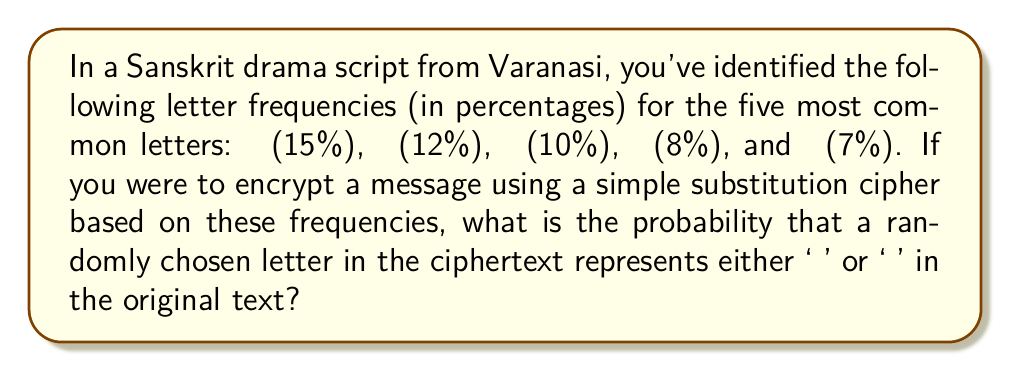Teach me how to tackle this problem. To solve this problem, we'll follow these steps:

1. Identify the relevant frequencies:
   म: 12%
   न: 10%

2. Calculate the probability of a letter being either 'म' or 'न':
   $P(\text{म or न}) = P(\text{म}) + P(\text{न})$

3. Convert percentages to probabilities:
   $P(\text{म}) = 12\% = 0.12$
   $P(\text{न}) = 10\% = 0.10$

4. Add the probabilities:
   $P(\text{म or न}) = 0.12 + 0.10 = 0.22$

5. Express the result as a percentage:
   $0.22 \times 100\% = 22\%$

Therefore, the probability that a randomly chosen letter in the ciphertext represents either 'म' or 'न' in the original text is 22%.
Answer: 22% 